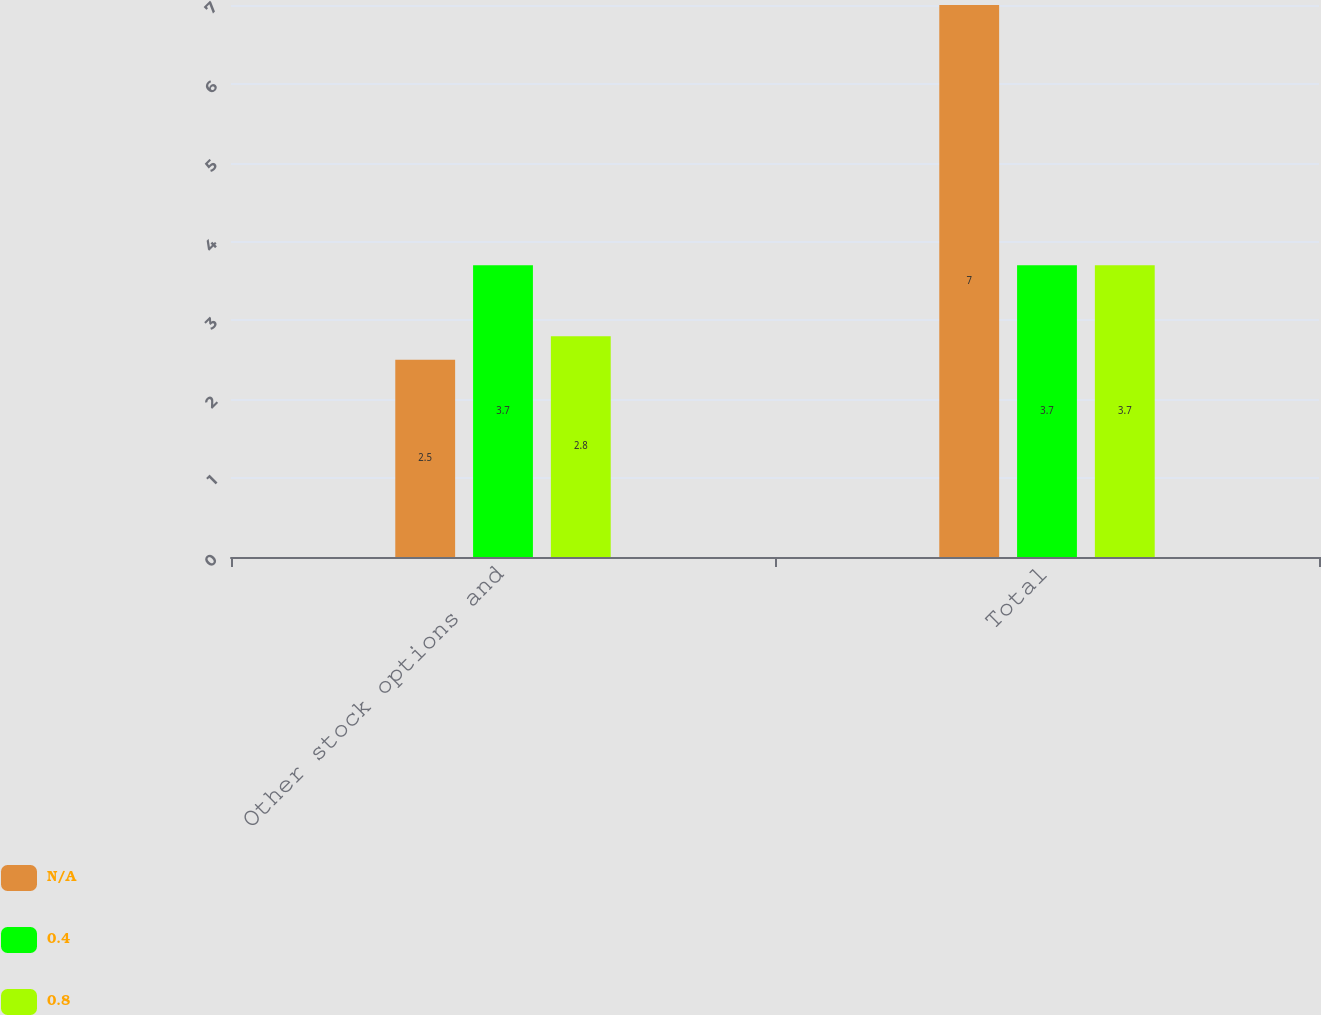Convert chart. <chart><loc_0><loc_0><loc_500><loc_500><stacked_bar_chart><ecel><fcel>Other stock options and<fcel>Total<nl><fcel>nan<fcel>2.5<fcel>7<nl><fcel>0.4<fcel>3.7<fcel>3.7<nl><fcel>0.8<fcel>2.8<fcel>3.7<nl></chart> 